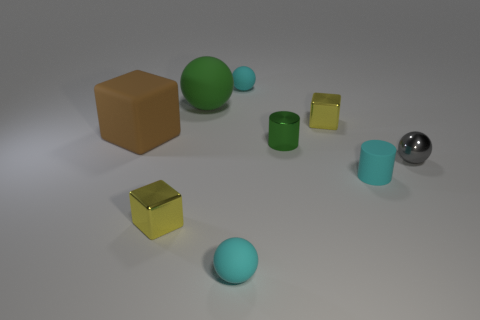Subtract all large rubber cubes. How many cubes are left? 2 Subtract all cyan cylinders. How many cyan balls are left? 2 Subtract all balls. How many objects are left? 5 Subtract 2 cylinders. How many cylinders are left? 0 Add 7 gray metal spheres. How many gray metal spheres are left? 8 Add 9 matte cylinders. How many matte cylinders exist? 10 Subtract all green spheres. How many spheres are left? 3 Subtract 0 red cylinders. How many objects are left? 9 Subtract all yellow cubes. Subtract all blue cylinders. How many cubes are left? 1 Subtract all blocks. Subtract all small cyan metal cubes. How many objects are left? 6 